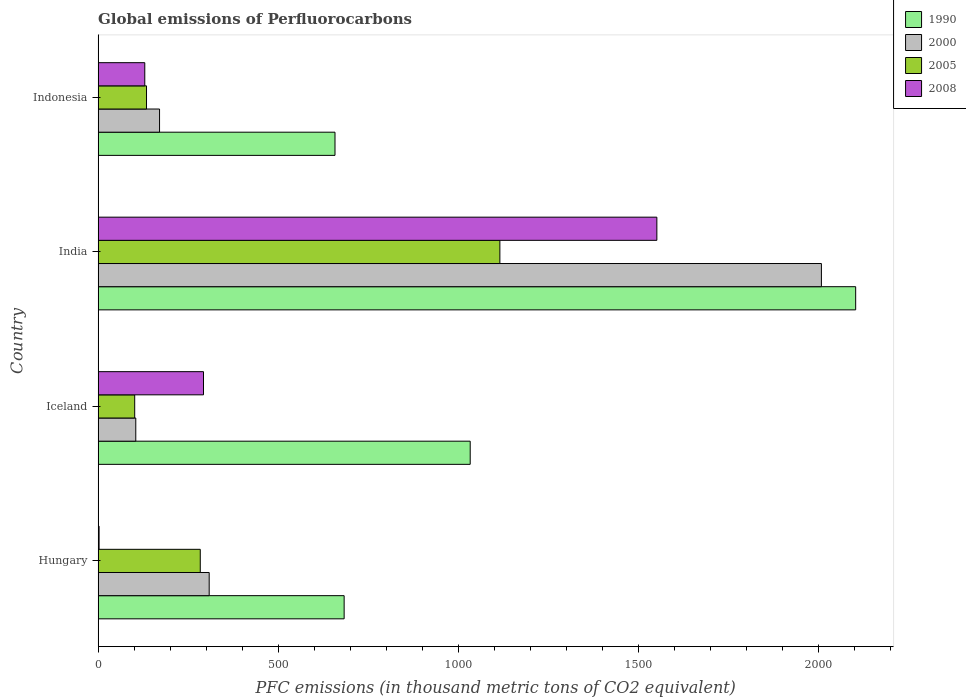How many different coloured bars are there?
Give a very brief answer. 4. How many groups of bars are there?
Provide a succinct answer. 4. Are the number of bars per tick equal to the number of legend labels?
Your response must be concise. Yes. Are the number of bars on each tick of the Y-axis equal?
Your answer should be very brief. Yes. How many bars are there on the 4th tick from the top?
Keep it short and to the point. 4. What is the global emissions of Perfluorocarbons in 2000 in Hungary?
Provide a succinct answer. 308.5. Across all countries, what is the maximum global emissions of Perfluorocarbons in 2005?
Your answer should be very brief. 1115.8. Across all countries, what is the minimum global emissions of Perfluorocarbons in 2000?
Provide a short and direct response. 104.6. What is the total global emissions of Perfluorocarbons in 1990 in the graph?
Provide a succinct answer. 4478.6. What is the difference between the global emissions of Perfluorocarbons in 1990 in Hungary and that in Iceland?
Offer a terse response. -350.1. What is the difference between the global emissions of Perfluorocarbons in 2005 in Iceland and the global emissions of Perfluorocarbons in 1990 in Indonesia?
Offer a terse response. -556.3. What is the average global emissions of Perfluorocarbons in 2005 per country?
Make the answer very short. 408.88. What is the difference between the global emissions of Perfluorocarbons in 2000 and global emissions of Perfluorocarbons in 2008 in India?
Make the answer very short. 457. What is the ratio of the global emissions of Perfluorocarbons in 2008 in Hungary to that in Indonesia?
Offer a very short reply. 0.02. Is the difference between the global emissions of Perfluorocarbons in 2000 in Hungary and Indonesia greater than the difference between the global emissions of Perfluorocarbons in 2008 in Hungary and Indonesia?
Your answer should be very brief. Yes. What is the difference between the highest and the second highest global emissions of Perfluorocarbons in 1990?
Offer a very short reply. 1070.6. What is the difference between the highest and the lowest global emissions of Perfluorocarbons in 2000?
Make the answer very short. 1904.2. In how many countries, is the global emissions of Perfluorocarbons in 1990 greater than the average global emissions of Perfluorocarbons in 1990 taken over all countries?
Make the answer very short. 1. Is it the case that in every country, the sum of the global emissions of Perfluorocarbons in 1990 and global emissions of Perfluorocarbons in 2008 is greater than the sum of global emissions of Perfluorocarbons in 2000 and global emissions of Perfluorocarbons in 2005?
Provide a succinct answer. Yes. What does the 4th bar from the top in India represents?
Give a very brief answer. 1990. What does the 4th bar from the bottom in Iceland represents?
Offer a terse response. 2008. How many bars are there?
Your response must be concise. 16. What is the difference between two consecutive major ticks on the X-axis?
Make the answer very short. 500. Does the graph contain grids?
Offer a terse response. No. Where does the legend appear in the graph?
Ensure brevity in your answer.  Top right. How many legend labels are there?
Your response must be concise. 4. What is the title of the graph?
Your answer should be compact. Global emissions of Perfluorocarbons. What is the label or title of the X-axis?
Offer a terse response. PFC emissions (in thousand metric tons of CO2 equivalent). What is the PFC emissions (in thousand metric tons of CO2 equivalent) of 1990 in Hungary?
Offer a very short reply. 683.3. What is the PFC emissions (in thousand metric tons of CO2 equivalent) in 2000 in Hungary?
Provide a succinct answer. 308.5. What is the PFC emissions (in thousand metric tons of CO2 equivalent) in 2005 in Hungary?
Offer a terse response. 283.7. What is the PFC emissions (in thousand metric tons of CO2 equivalent) of 1990 in Iceland?
Make the answer very short. 1033.4. What is the PFC emissions (in thousand metric tons of CO2 equivalent) of 2000 in Iceland?
Your answer should be compact. 104.6. What is the PFC emissions (in thousand metric tons of CO2 equivalent) in 2005 in Iceland?
Make the answer very short. 101.6. What is the PFC emissions (in thousand metric tons of CO2 equivalent) of 2008 in Iceland?
Provide a succinct answer. 292.7. What is the PFC emissions (in thousand metric tons of CO2 equivalent) of 1990 in India?
Your answer should be compact. 2104. What is the PFC emissions (in thousand metric tons of CO2 equivalent) of 2000 in India?
Keep it short and to the point. 2008.8. What is the PFC emissions (in thousand metric tons of CO2 equivalent) in 2005 in India?
Keep it short and to the point. 1115.8. What is the PFC emissions (in thousand metric tons of CO2 equivalent) in 2008 in India?
Ensure brevity in your answer.  1551.8. What is the PFC emissions (in thousand metric tons of CO2 equivalent) of 1990 in Indonesia?
Offer a very short reply. 657.9. What is the PFC emissions (in thousand metric tons of CO2 equivalent) of 2000 in Indonesia?
Your answer should be very brief. 170.6. What is the PFC emissions (in thousand metric tons of CO2 equivalent) of 2005 in Indonesia?
Keep it short and to the point. 134.4. What is the PFC emissions (in thousand metric tons of CO2 equivalent) in 2008 in Indonesia?
Offer a very short reply. 129.6. Across all countries, what is the maximum PFC emissions (in thousand metric tons of CO2 equivalent) in 1990?
Your answer should be compact. 2104. Across all countries, what is the maximum PFC emissions (in thousand metric tons of CO2 equivalent) of 2000?
Give a very brief answer. 2008.8. Across all countries, what is the maximum PFC emissions (in thousand metric tons of CO2 equivalent) in 2005?
Your answer should be very brief. 1115.8. Across all countries, what is the maximum PFC emissions (in thousand metric tons of CO2 equivalent) of 2008?
Provide a short and direct response. 1551.8. Across all countries, what is the minimum PFC emissions (in thousand metric tons of CO2 equivalent) in 1990?
Offer a terse response. 657.9. Across all countries, what is the minimum PFC emissions (in thousand metric tons of CO2 equivalent) of 2000?
Your answer should be very brief. 104.6. Across all countries, what is the minimum PFC emissions (in thousand metric tons of CO2 equivalent) of 2005?
Ensure brevity in your answer.  101.6. What is the total PFC emissions (in thousand metric tons of CO2 equivalent) in 1990 in the graph?
Your answer should be very brief. 4478.6. What is the total PFC emissions (in thousand metric tons of CO2 equivalent) of 2000 in the graph?
Offer a very short reply. 2592.5. What is the total PFC emissions (in thousand metric tons of CO2 equivalent) of 2005 in the graph?
Your response must be concise. 1635.5. What is the total PFC emissions (in thousand metric tons of CO2 equivalent) in 2008 in the graph?
Ensure brevity in your answer.  1976.8. What is the difference between the PFC emissions (in thousand metric tons of CO2 equivalent) in 1990 in Hungary and that in Iceland?
Provide a short and direct response. -350.1. What is the difference between the PFC emissions (in thousand metric tons of CO2 equivalent) of 2000 in Hungary and that in Iceland?
Give a very brief answer. 203.9. What is the difference between the PFC emissions (in thousand metric tons of CO2 equivalent) in 2005 in Hungary and that in Iceland?
Your answer should be very brief. 182.1. What is the difference between the PFC emissions (in thousand metric tons of CO2 equivalent) of 2008 in Hungary and that in Iceland?
Give a very brief answer. -290. What is the difference between the PFC emissions (in thousand metric tons of CO2 equivalent) in 1990 in Hungary and that in India?
Give a very brief answer. -1420.7. What is the difference between the PFC emissions (in thousand metric tons of CO2 equivalent) in 2000 in Hungary and that in India?
Make the answer very short. -1700.3. What is the difference between the PFC emissions (in thousand metric tons of CO2 equivalent) in 2005 in Hungary and that in India?
Your answer should be compact. -832.1. What is the difference between the PFC emissions (in thousand metric tons of CO2 equivalent) of 2008 in Hungary and that in India?
Make the answer very short. -1549.1. What is the difference between the PFC emissions (in thousand metric tons of CO2 equivalent) of 1990 in Hungary and that in Indonesia?
Provide a succinct answer. 25.4. What is the difference between the PFC emissions (in thousand metric tons of CO2 equivalent) of 2000 in Hungary and that in Indonesia?
Give a very brief answer. 137.9. What is the difference between the PFC emissions (in thousand metric tons of CO2 equivalent) in 2005 in Hungary and that in Indonesia?
Your answer should be compact. 149.3. What is the difference between the PFC emissions (in thousand metric tons of CO2 equivalent) in 2008 in Hungary and that in Indonesia?
Provide a short and direct response. -126.9. What is the difference between the PFC emissions (in thousand metric tons of CO2 equivalent) of 1990 in Iceland and that in India?
Provide a short and direct response. -1070.6. What is the difference between the PFC emissions (in thousand metric tons of CO2 equivalent) of 2000 in Iceland and that in India?
Ensure brevity in your answer.  -1904.2. What is the difference between the PFC emissions (in thousand metric tons of CO2 equivalent) of 2005 in Iceland and that in India?
Make the answer very short. -1014.2. What is the difference between the PFC emissions (in thousand metric tons of CO2 equivalent) of 2008 in Iceland and that in India?
Offer a very short reply. -1259.1. What is the difference between the PFC emissions (in thousand metric tons of CO2 equivalent) in 1990 in Iceland and that in Indonesia?
Provide a short and direct response. 375.5. What is the difference between the PFC emissions (in thousand metric tons of CO2 equivalent) in 2000 in Iceland and that in Indonesia?
Provide a short and direct response. -66. What is the difference between the PFC emissions (in thousand metric tons of CO2 equivalent) in 2005 in Iceland and that in Indonesia?
Keep it short and to the point. -32.8. What is the difference between the PFC emissions (in thousand metric tons of CO2 equivalent) in 2008 in Iceland and that in Indonesia?
Your answer should be very brief. 163.1. What is the difference between the PFC emissions (in thousand metric tons of CO2 equivalent) in 1990 in India and that in Indonesia?
Make the answer very short. 1446.1. What is the difference between the PFC emissions (in thousand metric tons of CO2 equivalent) of 2000 in India and that in Indonesia?
Give a very brief answer. 1838.2. What is the difference between the PFC emissions (in thousand metric tons of CO2 equivalent) in 2005 in India and that in Indonesia?
Provide a short and direct response. 981.4. What is the difference between the PFC emissions (in thousand metric tons of CO2 equivalent) in 2008 in India and that in Indonesia?
Offer a very short reply. 1422.2. What is the difference between the PFC emissions (in thousand metric tons of CO2 equivalent) of 1990 in Hungary and the PFC emissions (in thousand metric tons of CO2 equivalent) of 2000 in Iceland?
Ensure brevity in your answer.  578.7. What is the difference between the PFC emissions (in thousand metric tons of CO2 equivalent) in 1990 in Hungary and the PFC emissions (in thousand metric tons of CO2 equivalent) in 2005 in Iceland?
Keep it short and to the point. 581.7. What is the difference between the PFC emissions (in thousand metric tons of CO2 equivalent) of 1990 in Hungary and the PFC emissions (in thousand metric tons of CO2 equivalent) of 2008 in Iceland?
Provide a short and direct response. 390.6. What is the difference between the PFC emissions (in thousand metric tons of CO2 equivalent) in 2000 in Hungary and the PFC emissions (in thousand metric tons of CO2 equivalent) in 2005 in Iceland?
Your answer should be compact. 206.9. What is the difference between the PFC emissions (in thousand metric tons of CO2 equivalent) of 1990 in Hungary and the PFC emissions (in thousand metric tons of CO2 equivalent) of 2000 in India?
Give a very brief answer. -1325.5. What is the difference between the PFC emissions (in thousand metric tons of CO2 equivalent) in 1990 in Hungary and the PFC emissions (in thousand metric tons of CO2 equivalent) in 2005 in India?
Your answer should be very brief. -432.5. What is the difference between the PFC emissions (in thousand metric tons of CO2 equivalent) in 1990 in Hungary and the PFC emissions (in thousand metric tons of CO2 equivalent) in 2008 in India?
Offer a very short reply. -868.5. What is the difference between the PFC emissions (in thousand metric tons of CO2 equivalent) of 2000 in Hungary and the PFC emissions (in thousand metric tons of CO2 equivalent) of 2005 in India?
Your answer should be compact. -807.3. What is the difference between the PFC emissions (in thousand metric tons of CO2 equivalent) of 2000 in Hungary and the PFC emissions (in thousand metric tons of CO2 equivalent) of 2008 in India?
Your answer should be very brief. -1243.3. What is the difference between the PFC emissions (in thousand metric tons of CO2 equivalent) in 2005 in Hungary and the PFC emissions (in thousand metric tons of CO2 equivalent) in 2008 in India?
Offer a terse response. -1268.1. What is the difference between the PFC emissions (in thousand metric tons of CO2 equivalent) in 1990 in Hungary and the PFC emissions (in thousand metric tons of CO2 equivalent) in 2000 in Indonesia?
Keep it short and to the point. 512.7. What is the difference between the PFC emissions (in thousand metric tons of CO2 equivalent) in 1990 in Hungary and the PFC emissions (in thousand metric tons of CO2 equivalent) in 2005 in Indonesia?
Keep it short and to the point. 548.9. What is the difference between the PFC emissions (in thousand metric tons of CO2 equivalent) of 1990 in Hungary and the PFC emissions (in thousand metric tons of CO2 equivalent) of 2008 in Indonesia?
Your answer should be compact. 553.7. What is the difference between the PFC emissions (in thousand metric tons of CO2 equivalent) of 2000 in Hungary and the PFC emissions (in thousand metric tons of CO2 equivalent) of 2005 in Indonesia?
Provide a short and direct response. 174.1. What is the difference between the PFC emissions (in thousand metric tons of CO2 equivalent) of 2000 in Hungary and the PFC emissions (in thousand metric tons of CO2 equivalent) of 2008 in Indonesia?
Your answer should be compact. 178.9. What is the difference between the PFC emissions (in thousand metric tons of CO2 equivalent) of 2005 in Hungary and the PFC emissions (in thousand metric tons of CO2 equivalent) of 2008 in Indonesia?
Give a very brief answer. 154.1. What is the difference between the PFC emissions (in thousand metric tons of CO2 equivalent) in 1990 in Iceland and the PFC emissions (in thousand metric tons of CO2 equivalent) in 2000 in India?
Keep it short and to the point. -975.4. What is the difference between the PFC emissions (in thousand metric tons of CO2 equivalent) of 1990 in Iceland and the PFC emissions (in thousand metric tons of CO2 equivalent) of 2005 in India?
Ensure brevity in your answer.  -82.4. What is the difference between the PFC emissions (in thousand metric tons of CO2 equivalent) in 1990 in Iceland and the PFC emissions (in thousand metric tons of CO2 equivalent) in 2008 in India?
Ensure brevity in your answer.  -518.4. What is the difference between the PFC emissions (in thousand metric tons of CO2 equivalent) in 2000 in Iceland and the PFC emissions (in thousand metric tons of CO2 equivalent) in 2005 in India?
Offer a very short reply. -1011.2. What is the difference between the PFC emissions (in thousand metric tons of CO2 equivalent) of 2000 in Iceland and the PFC emissions (in thousand metric tons of CO2 equivalent) of 2008 in India?
Your answer should be very brief. -1447.2. What is the difference between the PFC emissions (in thousand metric tons of CO2 equivalent) in 2005 in Iceland and the PFC emissions (in thousand metric tons of CO2 equivalent) in 2008 in India?
Your response must be concise. -1450.2. What is the difference between the PFC emissions (in thousand metric tons of CO2 equivalent) of 1990 in Iceland and the PFC emissions (in thousand metric tons of CO2 equivalent) of 2000 in Indonesia?
Keep it short and to the point. 862.8. What is the difference between the PFC emissions (in thousand metric tons of CO2 equivalent) in 1990 in Iceland and the PFC emissions (in thousand metric tons of CO2 equivalent) in 2005 in Indonesia?
Offer a terse response. 899. What is the difference between the PFC emissions (in thousand metric tons of CO2 equivalent) in 1990 in Iceland and the PFC emissions (in thousand metric tons of CO2 equivalent) in 2008 in Indonesia?
Make the answer very short. 903.8. What is the difference between the PFC emissions (in thousand metric tons of CO2 equivalent) in 2000 in Iceland and the PFC emissions (in thousand metric tons of CO2 equivalent) in 2005 in Indonesia?
Give a very brief answer. -29.8. What is the difference between the PFC emissions (in thousand metric tons of CO2 equivalent) in 2005 in Iceland and the PFC emissions (in thousand metric tons of CO2 equivalent) in 2008 in Indonesia?
Provide a short and direct response. -28. What is the difference between the PFC emissions (in thousand metric tons of CO2 equivalent) of 1990 in India and the PFC emissions (in thousand metric tons of CO2 equivalent) of 2000 in Indonesia?
Give a very brief answer. 1933.4. What is the difference between the PFC emissions (in thousand metric tons of CO2 equivalent) of 1990 in India and the PFC emissions (in thousand metric tons of CO2 equivalent) of 2005 in Indonesia?
Your response must be concise. 1969.6. What is the difference between the PFC emissions (in thousand metric tons of CO2 equivalent) in 1990 in India and the PFC emissions (in thousand metric tons of CO2 equivalent) in 2008 in Indonesia?
Give a very brief answer. 1974.4. What is the difference between the PFC emissions (in thousand metric tons of CO2 equivalent) in 2000 in India and the PFC emissions (in thousand metric tons of CO2 equivalent) in 2005 in Indonesia?
Keep it short and to the point. 1874.4. What is the difference between the PFC emissions (in thousand metric tons of CO2 equivalent) of 2000 in India and the PFC emissions (in thousand metric tons of CO2 equivalent) of 2008 in Indonesia?
Provide a succinct answer. 1879.2. What is the difference between the PFC emissions (in thousand metric tons of CO2 equivalent) in 2005 in India and the PFC emissions (in thousand metric tons of CO2 equivalent) in 2008 in Indonesia?
Provide a short and direct response. 986.2. What is the average PFC emissions (in thousand metric tons of CO2 equivalent) in 1990 per country?
Offer a very short reply. 1119.65. What is the average PFC emissions (in thousand metric tons of CO2 equivalent) in 2000 per country?
Give a very brief answer. 648.12. What is the average PFC emissions (in thousand metric tons of CO2 equivalent) of 2005 per country?
Your answer should be compact. 408.88. What is the average PFC emissions (in thousand metric tons of CO2 equivalent) in 2008 per country?
Give a very brief answer. 494.2. What is the difference between the PFC emissions (in thousand metric tons of CO2 equivalent) in 1990 and PFC emissions (in thousand metric tons of CO2 equivalent) in 2000 in Hungary?
Make the answer very short. 374.8. What is the difference between the PFC emissions (in thousand metric tons of CO2 equivalent) in 1990 and PFC emissions (in thousand metric tons of CO2 equivalent) in 2005 in Hungary?
Ensure brevity in your answer.  399.6. What is the difference between the PFC emissions (in thousand metric tons of CO2 equivalent) in 1990 and PFC emissions (in thousand metric tons of CO2 equivalent) in 2008 in Hungary?
Your answer should be very brief. 680.6. What is the difference between the PFC emissions (in thousand metric tons of CO2 equivalent) of 2000 and PFC emissions (in thousand metric tons of CO2 equivalent) of 2005 in Hungary?
Your answer should be very brief. 24.8. What is the difference between the PFC emissions (in thousand metric tons of CO2 equivalent) in 2000 and PFC emissions (in thousand metric tons of CO2 equivalent) in 2008 in Hungary?
Make the answer very short. 305.8. What is the difference between the PFC emissions (in thousand metric tons of CO2 equivalent) of 2005 and PFC emissions (in thousand metric tons of CO2 equivalent) of 2008 in Hungary?
Offer a very short reply. 281. What is the difference between the PFC emissions (in thousand metric tons of CO2 equivalent) of 1990 and PFC emissions (in thousand metric tons of CO2 equivalent) of 2000 in Iceland?
Give a very brief answer. 928.8. What is the difference between the PFC emissions (in thousand metric tons of CO2 equivalent) in 1990 and PFC emissions (in thousand metric tons of CO2 equivalent) in 2005 in Iceland?
Give a very brief answer. 931.8. What is the difference between the PFC emissions (in thousand metric tons of CO2 equivalent) in 1990 and PFC emissions (in thousand metric tons of CO2 equivalent) in 2008 in Iceland?
Make the answer very short. 740.7. What is the difference between the PFC emissions (in thousand metric tons of CO2 equivalent) in 2000 and PFC emissions (in thousand metric tons of CO2 equivalent) in 2005 in Iceland?
Ensure brevity in your answer.  3. What is the difference between the PFC emissions (in thousand metric tons of CO2 equivalent) in 2000 and PFC emissions (in thousand metric tons of CO2 equivalent) in 2008 in Iceland?
Your response must be concise. -188.1. What is the difference between the PFC emissions (in thousand metric tons of CO2 equivalent) in 2005 and PFC emissions (in thousand metric tons of CO2 equivalent) in 2008 in Iceland?
Offer a very short reply. -191.1. What is the difference between the PFC emissions (in thousand metric tons of CO2 equivalent) of 1990 and PFC emissions (in thousand metric tons of CO2 equivalent) of 2000 in India?
Give a very brief answer. 95.2. What is the difference between the PFC emissions (in thousand metric tons of CO2 equivalent) in 1990 and PFC emissions (in thousand metric tons of CO2 equivalent) in 2005 in India?
Provide a succinct answer. 988.2. What is the difference between the PFC emissions (in thousand metric tons of CO2 equivalent) in 1990 and PFC emissions (in thousand metric tons of CO2 equivalent) in 2008 in India?
Make the answer very short. 552.2. What is the difference between the PFC emissions (in thousand metric tons of CO2 equivalent) of 2000 and PFC emissions (in thousand metric tons of CO2 equivalent) of 2005 in India?
Give a very brief answer. 893. What is the difference between the PFC emissions (in thousand metric tons of CO2 equivalent) of 2000 and PFC emissions (in thousand metric tons of CO2 equivalent) of 2008 in India?
Offer a terse response. 457. What is the difference between the PFC emissions (in thousand metric tons of CO2 equivalent) of 2005 and PFC emissions (in thousand metric tons of CO2 equivalent) of 2008 in India?
Offer a terse response. -436. What is the difference between the PFC emissions (in thousand metric tons of CO2 equivalent) in 1990 and PFC emissions (in thousand metric tons of CO2 equivalent) in 2000 in Indonesia?
Make the answer very short. 487.3. What is the difference between the PFC emissions (in thousand metric tons of CO2 equivalent) in 1990 and PFC emissions (in thousand metric tons of CO2 equivalent) in 2005 in Indonesia?
Offer a terse response. 523.5. What is the difference between the PFC emissions (in thousand metric tons of CO2 equivalent) in 1990 and PFC emissions (in thousand metric tons of CO2 equivalent) in 2008 in Indonesia?
Keep it short and to the point. 528.3. What is the difference between the PFC emissions (in thousand metric tons of CO2 equivalent) of 2000 and PFC emissions (in thousand metric tons of CO2 equivalent) of 2005 in Indonesia?
Offer a very short reply. 36.2. What is the ratio of the PFC emissions (in thousand metric tons of CO2 equivalent) of 1990 in Hungary to that in Iceland?
Give a very brief answer. 0.66. What is the ratio of the PFC emissions (in thousand metric tons of CO2 equivalent) of 2000 in Hungary to that in Iceland?
Provide a succinct answer. 2.95. What is the ratio of the PFC emissions (in thousand metric tons of CO2 equivalent) in 2005 in Hungary to that in Iceland?
Make the answer very short. 2.79. What is the ratio of the PFC emissions (in thousand metric tons of CO2 equivalent) in 2008 in Hungary to that in Iceland?
Offer a terse response. 0.01. What is the ratio of the PFC emissions (in thousand metric tons of CO2 equivalent) in 1990 in Hungary to that in India?
Offer a very short reply. 0.32. What is the ratio of the PFC emissions (in thousand metric tons of CO2 equivalent) of 2000 in Hungary to that in India?
Your answer should be very brief. 0.15. What is the ratio of the PFC emissions (in thousand metric tons of CO2 equivalent) of 2005 in Hungary to that in India?
Offer a very short reply. 0.25. What is the ratio of the PFC emissions (in thousand metric tons of CO2 equivalent) in 2008 in Hungary to that in India?
Offer a very short reply. 0. What is the ratio of the PFC emissions (in thousand metric tons of CO2 equivalent) in 1990 in Hungary to that in Indonesia?
Your answer should be very brief. 1.04. What is the ratio of the PFC emissions (in thousand metric tons of CO2 equivalent) in 2000 in Hungary to that in Indonesia?
Provide a short and direct response. 1.81. What is the ratio of the PFC emissions (in thousand metric tons of CO2 equivalent) in 2005 in Hungary to that in Indonesia?
Ensure brevity in your answer.  2.11. What is the ratio of the PFC emissions (in thousand metric tons of CO2 equivalent) of 2008 in Hungary to that in Indonesia?
Offer a very short reply. 0.02. What is the ratio of the PFC emissions (in thousand metric tons of CO2 equivalent) in 1990 in Iceland to that in India?
Give a very brief answer. 0.49. What is the ratio of the PFC emissions (in thousand metric tons of CO2 equivalent) of 2000 in Iceland to that in India?
Make the answer very short. 0.05. What is the ratio of the PFC emissions (in thousand metric tons of CO2 equivalent) of 2005 in Iceland to that in India?
Ensure brevity in your answer.  0.09. What is the ratio of the PFC emissions (in thousand metric tons of CO2 equivalent) in 2008 in Iceland to that in India?
Your answer should be compact. 0.19. What is the ratio of the PFC emissions (in thousand metric tons of CO2 equivalent) in 1990 in Iceland to that in Indonesia?
Give a very brief answer. 1.57. What is the ratio of the PFC emissions (in thousand metric tons of CO2 equivalent) in 2000 in Iceland to that in Indonesia?
Provide a succinct answer. 0.61. What is the ratio of the PFC emissions (in thousand metric tons of CO2 equivalent) of 2005 in Iceland to that in Indonesia?
Ensure brevity in your answer.  0.76. What is the ratio of the PFC emissions (in thousand metric tons of CO2 equivalent) of 2008 in Iceland to that in Indonesia?
Offer a terse response. 2.26. What is the ratio of the PFC emissions (in thousand metric tons of CO2 equivalent) in 1990 in India to that in Indonesia?
Your answer should be compact. 3.2. What is the ratio of the PFC emissions (in thousand metric tons of CO2 equivalent) in 2000 in India to that in Indonesia?
Offer a very short reply. 11.77. What is the ratio of the PFC emissions (in thousand metric tons of CO2 equivalent) in 2005 in India to that in Indonesia?
Your answer should be very brief. 8.3. What is the ratio of the PFC emissions (in thousand metric tons of CO2 equivalent) in 2008 in India to that in Indonesia?
Offer a terse response. 11.97. What is the difference between the highest and the second highest PFC emissions (in thousand metric tons of CO2 equivalent) of 1990?
Ensure brevity in your answer.  1070.6. What is the difference between the highest and the second highest PFC emissions (in thousand metric tons of CO2 equivalent) in 2000?
Your answer should be very brief. 1700.3. What is the difference between the highest and the second highest PFC emissions (in thousand metric tons of CO2 equivalent) in 2005?
Make the answer very short. 832.1. What is the difference between the highest and the second highest PFC emissions (in thousand metric tons of CO2 equivalent) in 2008?
Give a very brief answer. 1259.1. What is the difference between the highest and the lowest PFC emissions (in thousand metric tons of CO2 equivalent) of 1990?
Your answer should be very brief. 1446.1. What is the difference between the highest and the lowest PFC emissions (in thousand metric tons of CO2 equivalent) in 2000?
Your answer should be compact. 1904.2. What is the difference between the highest and the lowest PFC emissions (in thousand metric tons of CO2 equivalent) in 2005?
Provide a short and direct response. 1014.2. What is the difference between the highest and the lowest PFC emissions (in thousand metric tons of CO2 equivalent) of 2008?
Ensure brevity in your answer.  1549.1. 